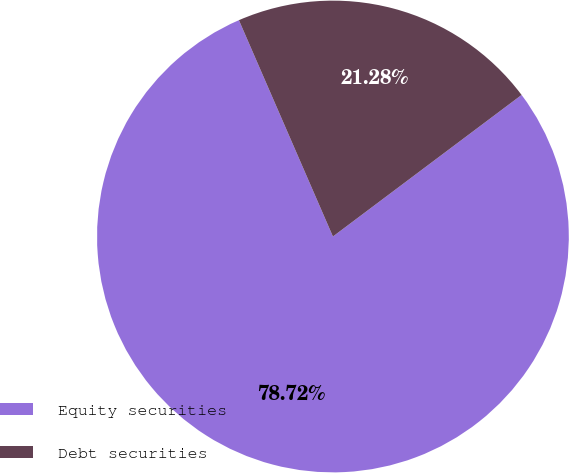Convert chart. <chart><loc_0><loc_0><loc_500><loc_500><pie_chart><fcel>Equity securities<fcel>Debt securities<nl><fcel>78.72%<fcel>21.28%<nl></chart> 